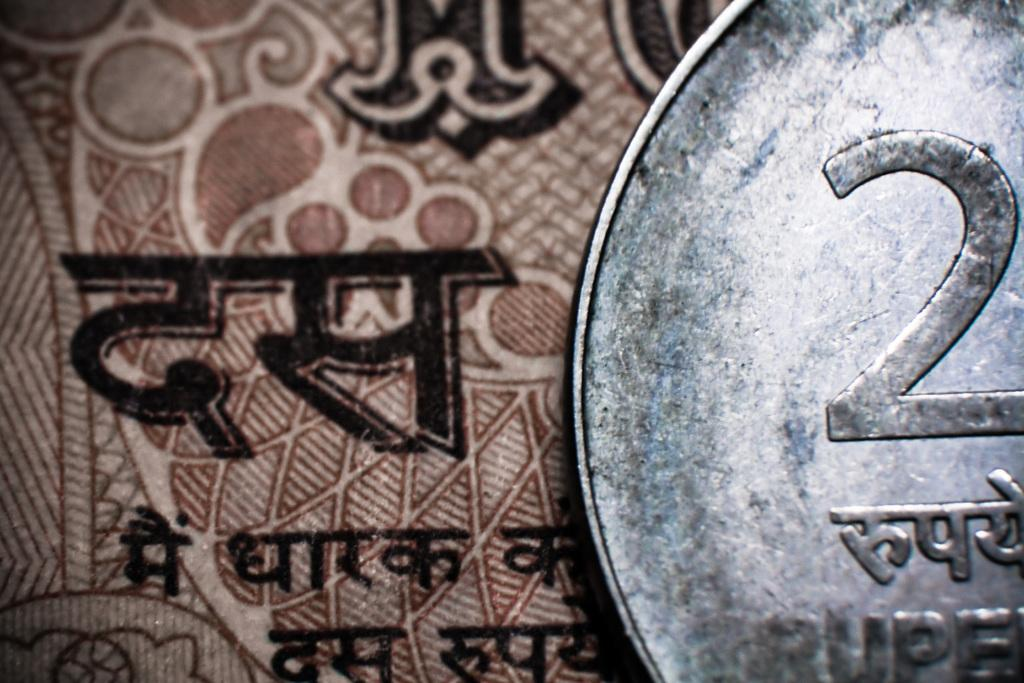What is the main object in the image? There is a silver coin in the image. What can be seen on the silver coin? The silver coin has the number "2" on it. What else is present in the image besides the silver coin? There is a paper in the image. What language is written on the paper? The paper has matter written in Hindi. In which direction is the silver coin facing in the image? The direction the silver coin is facing cannot be determined from the image, as it is a flat object. --- 